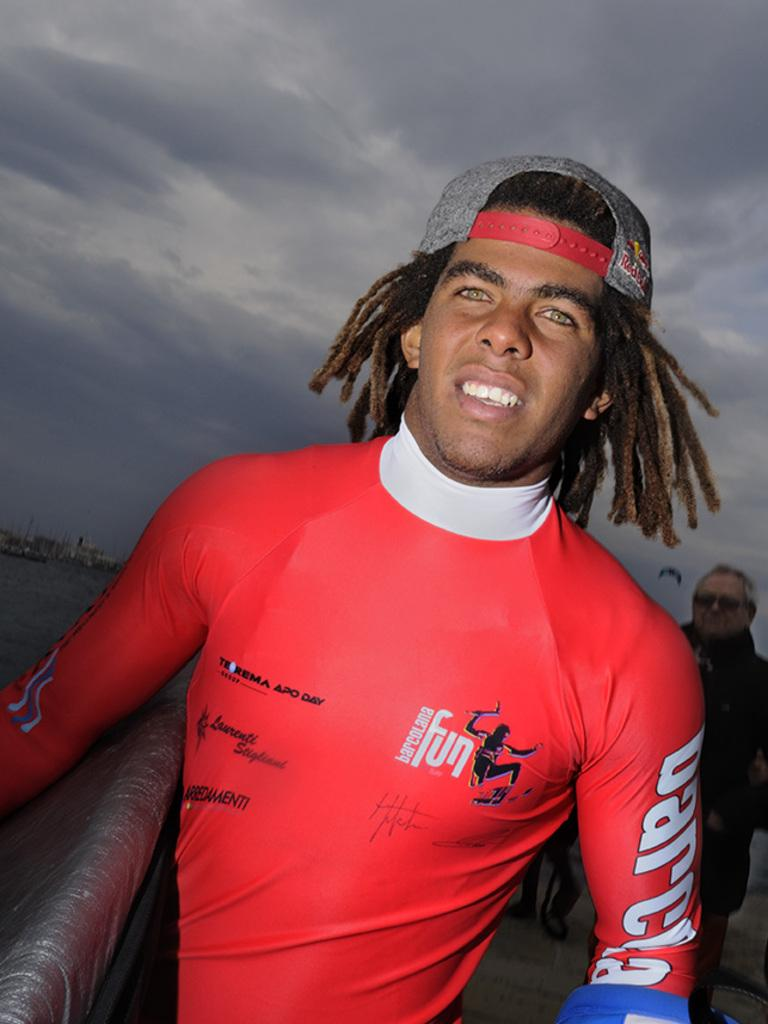<image>
Relay a brief, clear account of the picture shown. A man wears a red shirt with Barcelona fun printed on it. 